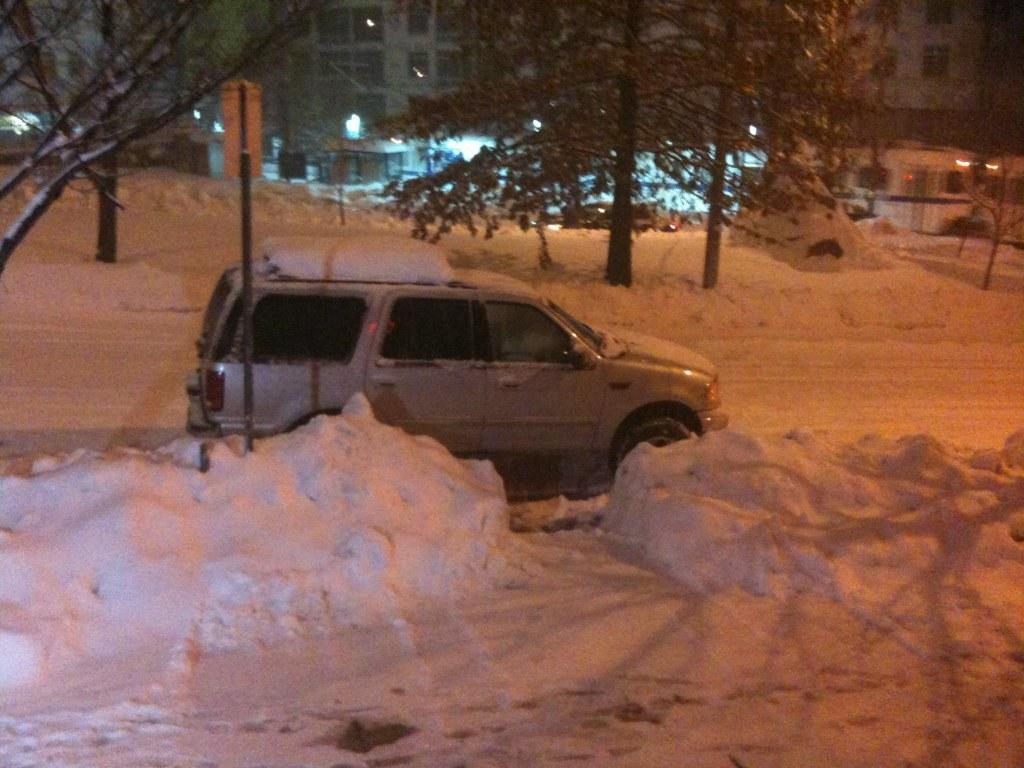What is the main subject of the image? There is a car in the image. What is the condition of the ground around the car? The car is in the snow. What type of natural environment can be seen in the image? There are trees visible in the image. What type of man-made structures are present in the image? There are buildings in the image. How many bears can be seen interacting with the car in the image? There are no bears present in the image; it features a car in the snow with trees and buildings in the background. What level of industrialization is depicted in the image? The image does not depict any specific level of industrialization; it simply shows a car in the snow with trees and buildings in the background. 